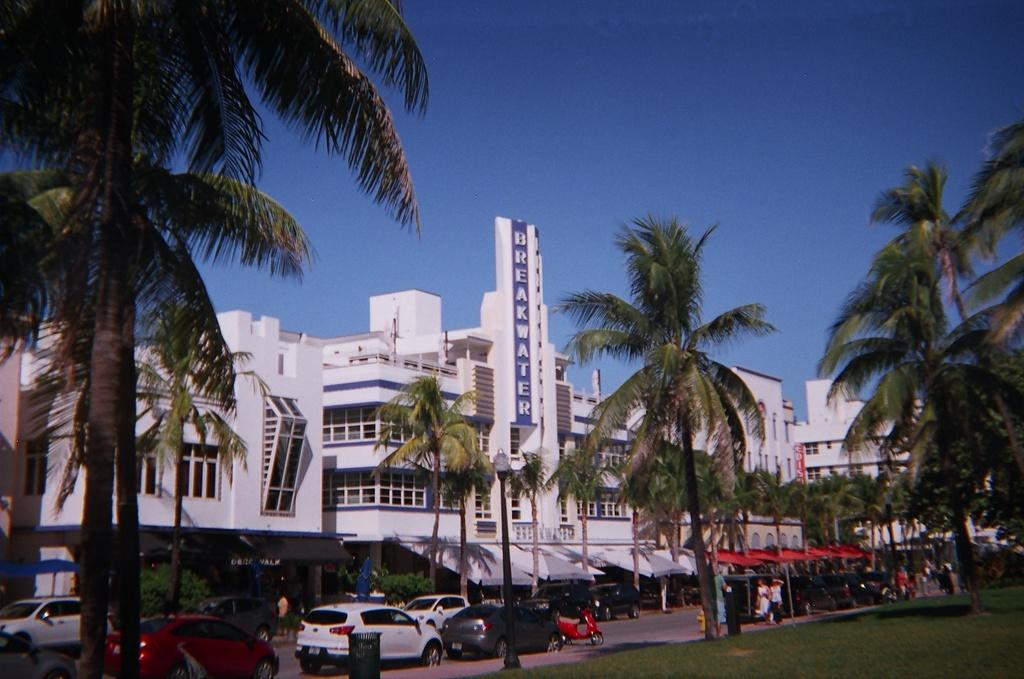What can be seen on the road in the image? There are vehicles on the road in the image. What type of vegetation is visible in the image? There is grass visible in the image, as well as trees. What object is present for waste disposal? There is a bin in the image. What type of structures can be seen in the image? There are buildings in the image. What are the boards used for in the image? The purpose of the boards in the image is not clear, but they might be used for signage or advertising. How many persons are present in the image? There are persons in the image, but the exact number is not specified. What is visible in the background of the image? The sky is visible in the background of the image. Can you tell me how many deer are swimming in the image? There are no deer present in the image, and no swimming is depicted. 